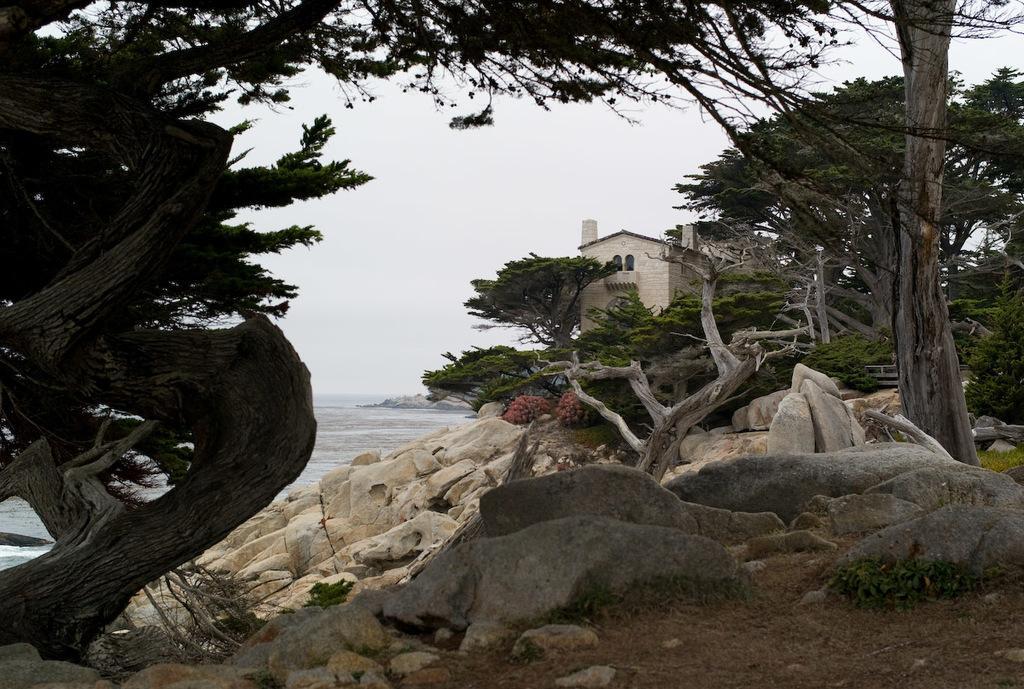Can you describe this image briefly? In this image we can see the rocks and also trees. We can also see the beach and a house. Sky is also visible. 